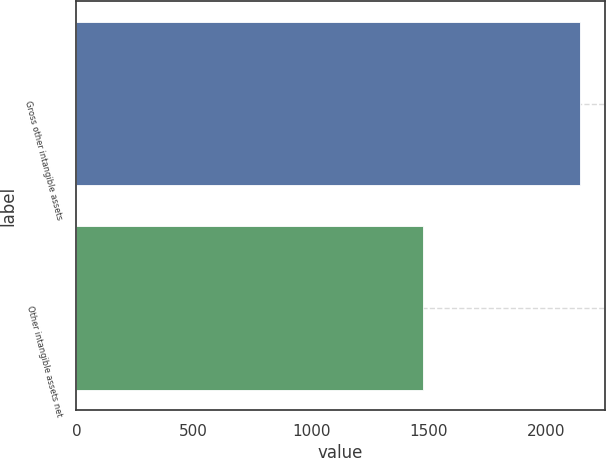<chart> <loc_0><loc_0><loc_500><loc_500><bar_chart><fcel>Gross other intangible assets<fcel>Other intangible assets net<nl><fcel>2144<fcel>1479<nl></chart> 